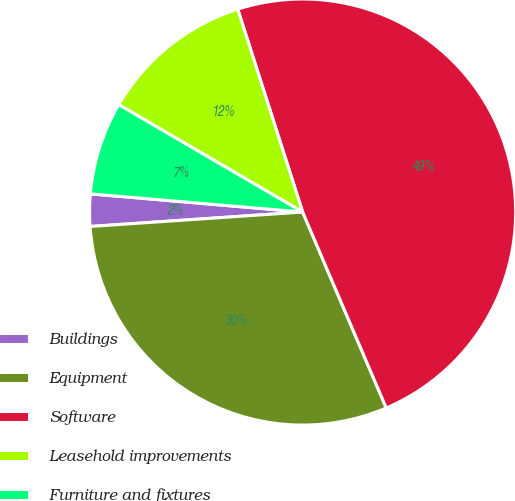<chart> <loc_0><loc_0><loc_500><loc_500><pie_chart><fcel>Buildings<fcel>Equipment<fcel>Software<fcel>Leasehold improvements<fcel>Furniture and fixtures<nl><fcel>2.44%<fcel>30.34%<fcel>48.51%<fcel>11.66%<fcel>7.05%<nl></chart> 